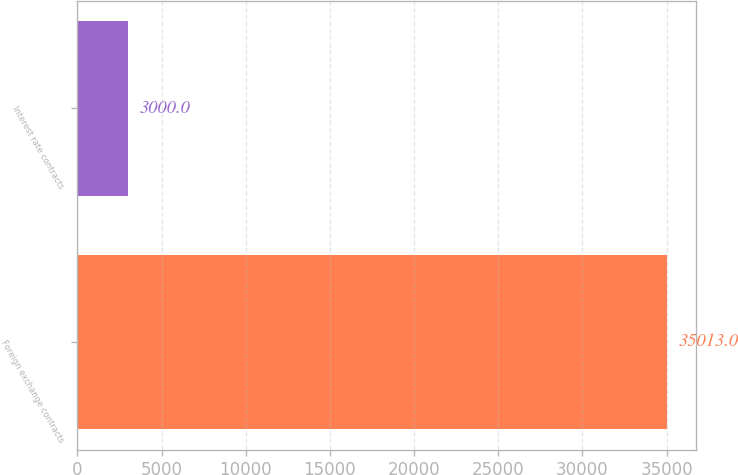Convert chart. <chart><loc_0><loc_0><loc_500><loc_500><bar_chart><fcel>Foreign exchange contracts<fcel>Interest rate contracts<nl><fcel>35013<fcel>3000<nl></chart> 